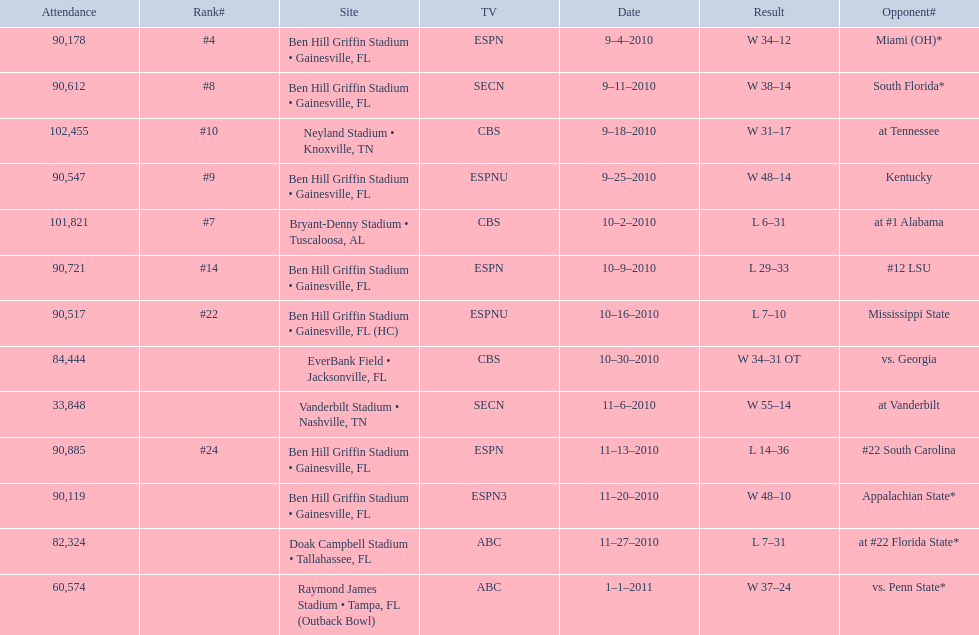How many games did the university of florida win by at least 10 points? 7. 